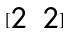Convert formula to latex. <formula><loc_0><loc_0><loc_500><loc_500>[ \begin{matrix} 2 & 2 \end{matrix} ]</formula> 